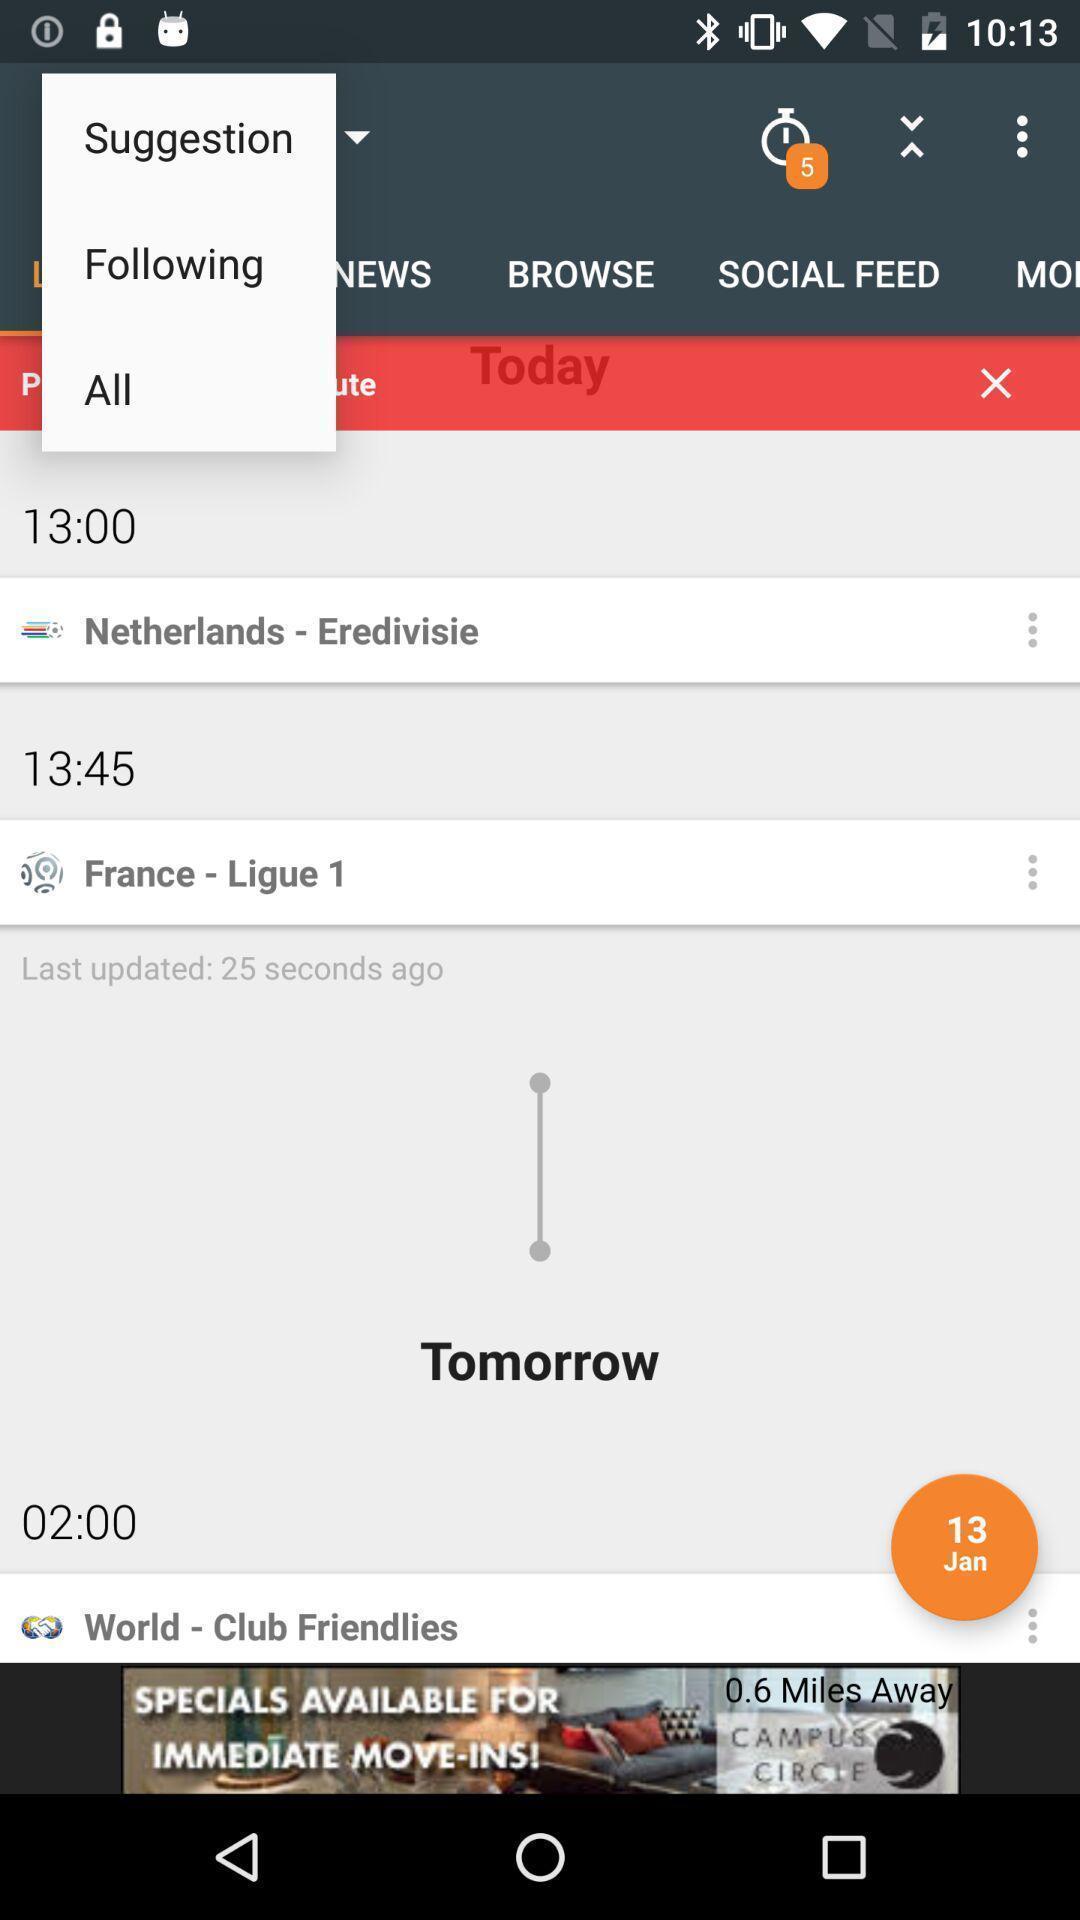Provide a textual representation of this image. Screen is showing today updates an sports application. 